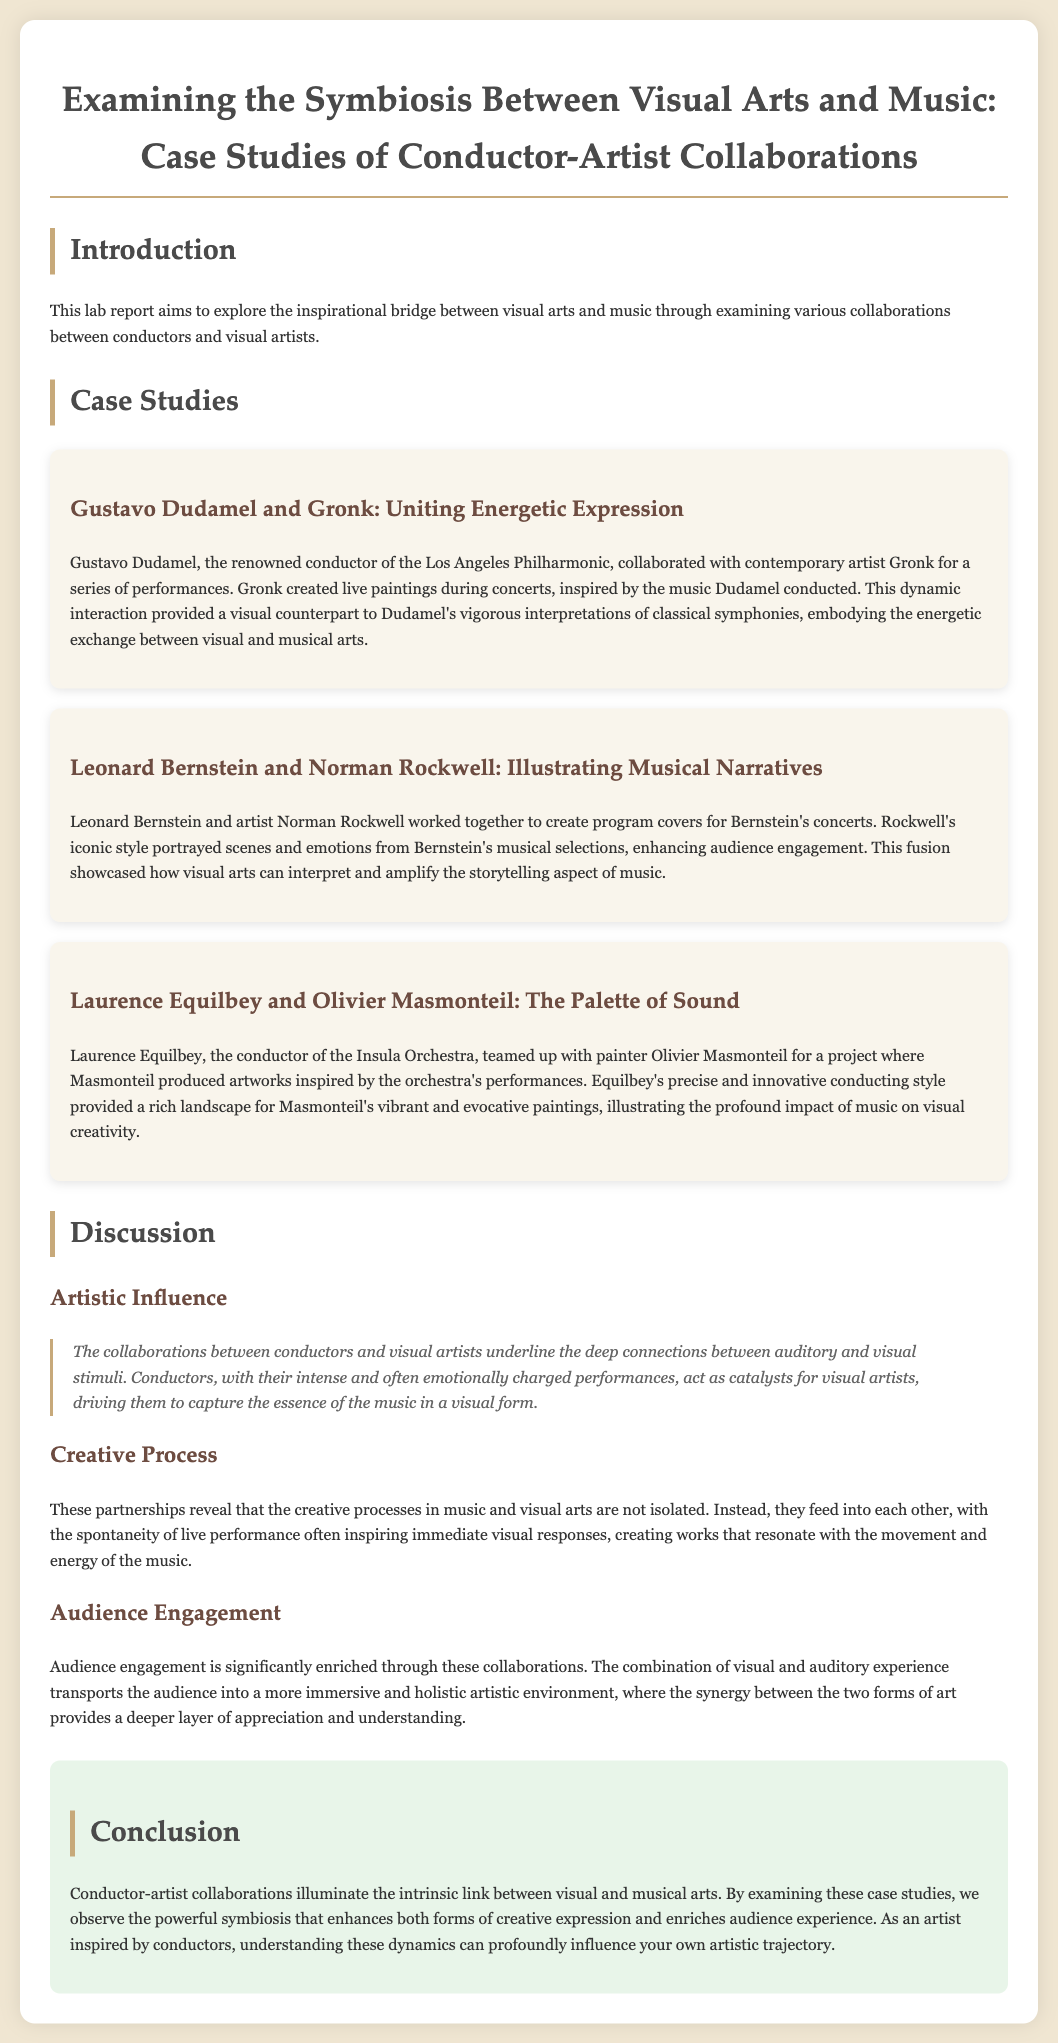what is the main aim of this lab report? The lab report aims to explore the inspirational bridge between visual arts and music through examining various collaborations.
Answer: exploring the inspirational bridge between visual arts and music who collaborated with Gustavo Dudamel? The document mentions Gronk as the artist who collaborated with Gustavo Dudamel.
Answer: Gronk what was one of the outcomes of Dudamel's collaboration with Gronk? The dynamic interaction provided a visual counterpart to Dudamel's vigorous interpretations of classical symphonies.
Answer: visual counterpart which conductor worked with Norman Rockwell? The conductor who worked with Norman Rockwell is Leonard Bernstein.
Answer: Leonard Bernstein how does the report describe the role of conductors in these collaborations? Conductors act as catalysts for visual artists, driving them to capture the essence of the music.
Answer: catalysts for visual artists what type of artistic experience do the collaborations aim to enhance? The collaborations aim to enhance audience engagement through a combination of visual and auditory experience.
Answer: audience engagement what conclusion is drawn about conductor-artist collaborations? The conclusion states that these collaborations illuminate the intrinsic link between visual and musical arts.
Answer: intrinsic link between visual and musical arts how does the document categorize the creative processes in music and visual arts? The document states that the creative processes in music and visual arts are not isolated; they feed into each other.
Answer: not isolated; they feed into each other what is the color scheme used in the report's background? The background color scheme of the document is #f0e6d2.
Answer: #f0e6d2 